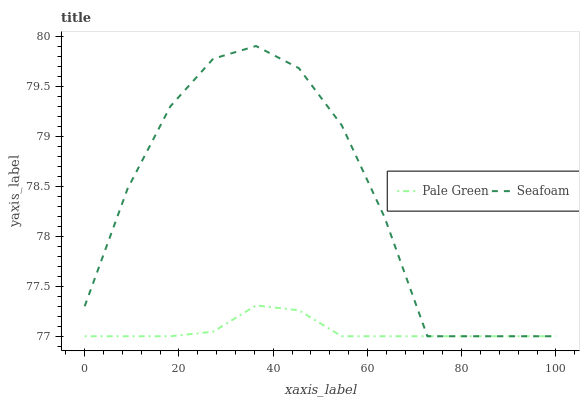Does Pale Green have the minimum area under the curve?
Answer yes or no. Yes. Does Seafoam have the maximum area under the curve?
Answer yes or no. Yes. Does Seafoam have the minimum area under the curve?
Answer yes or no. No. Is Pale Green the smoothest?
Answer yes or no. Yes. Is Seafoam the roughest?
Answer yes or no. Yes. Is Seafoam the smoothest?
Answer yes or no. No. Does Pale Green have the lowest value?
Answer yes or no. Yes. Does Seafoam have the highest value?
Answer yes or no. Yes. Does Pale Green intersect Seafoam?
Answer yes or no. Yes. Is Pale Green less than Seafoam?
Answer yes or no. No. Is Pale Green greater than Seafoam?
Answer yes or no. No. 